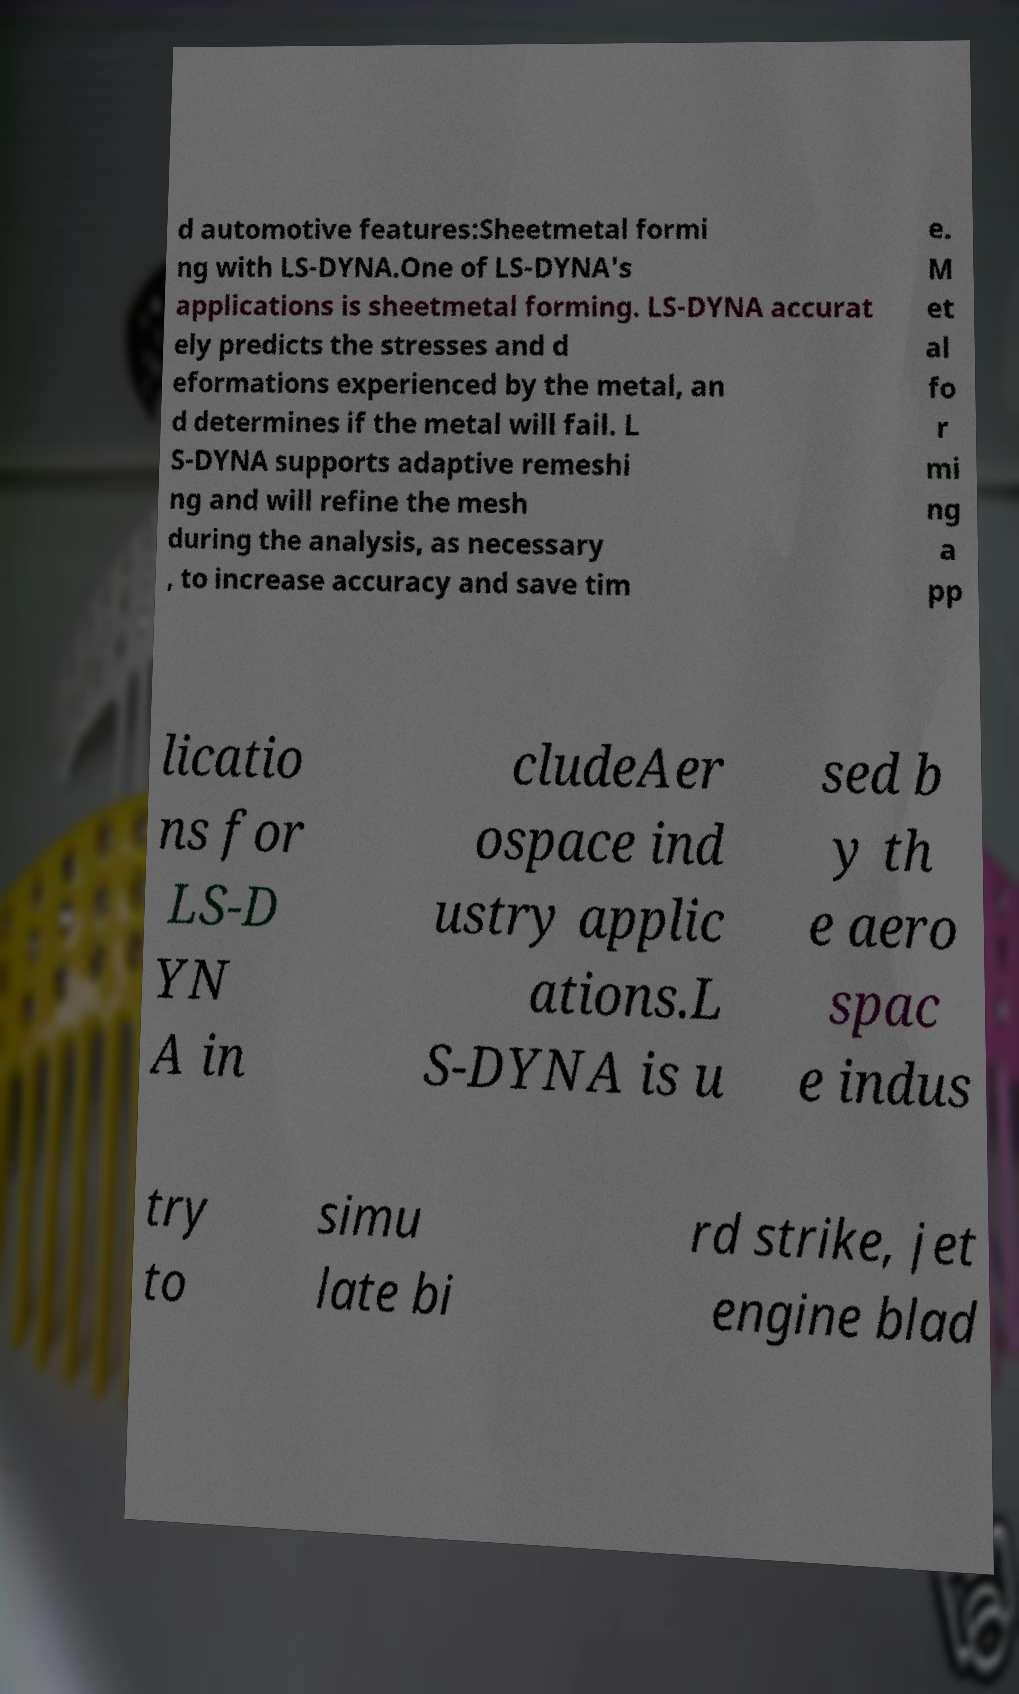Can you read and provide the text displayed in the image?This photo seems to have some interesting text. Can you extract and type it out for me? d automotive features:Sheetmetal formi ng with LS-DYNA.One of LS-DYNA's applications is sheetmetal forming. LS-DYNA accurat ely predicts the stresses and d eformations experienced by the metal, an d determines if the metal will fail. L S-DYNA supports adaptive remeshi ng and will refine the mesh during the analysis, as necessary , to increase accuracy and save tim e. M et al fo r mi ng a pp licatio ns for LS-D YN A in cludeAer ospace ind ustry applic ations.L S-DYNA is u sed b y th e aero spac e indus try to simu late bi rd strike, jet engine blad 